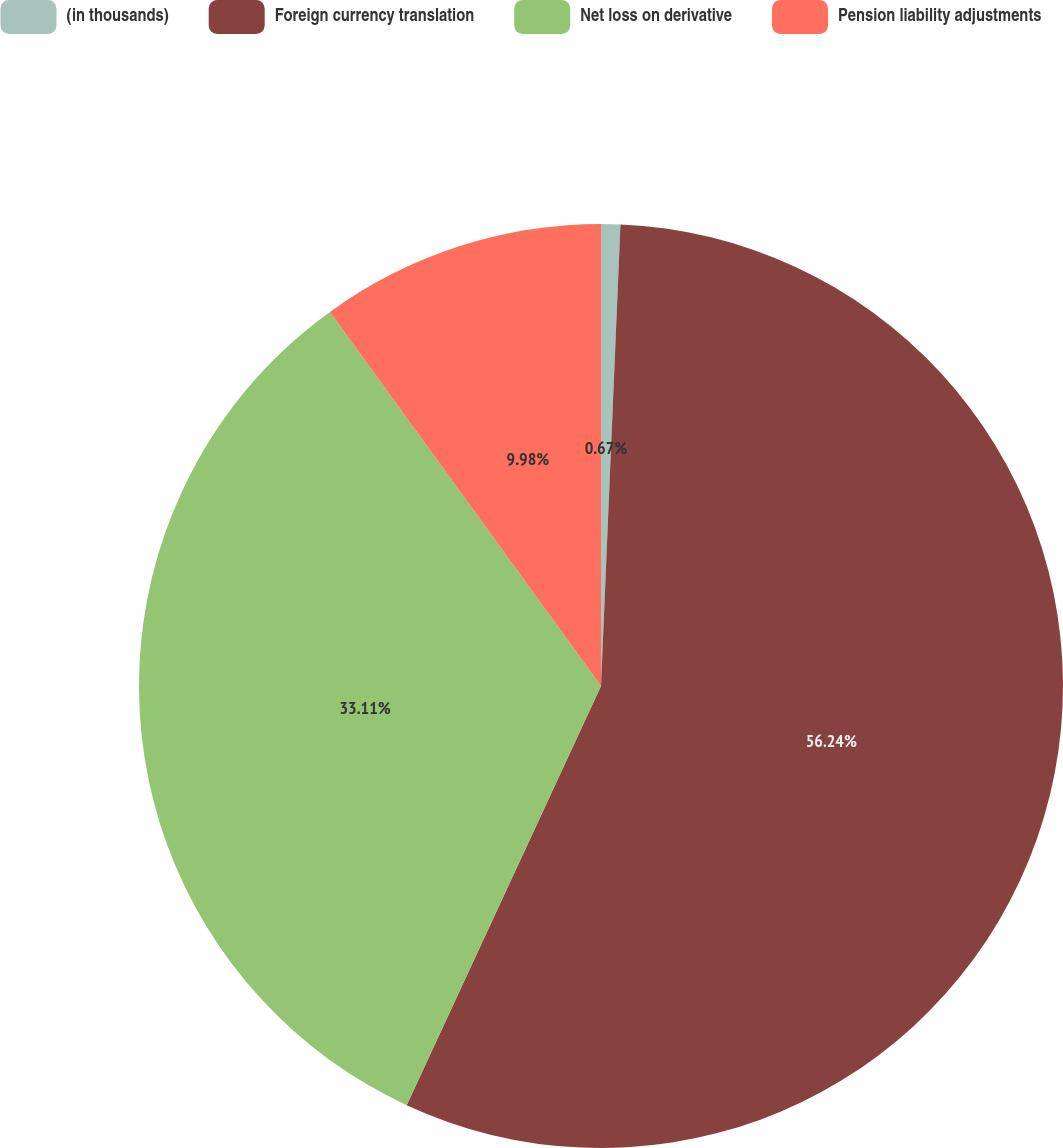Convert chart. <chart><loc_0><loc_0><loc_500><loc_500><pie_chart><fcel>(in thousands)<fcel>Foreign currency translation<fcel>Net loss on derivative<fcel>Pension liability adjustments<nl><fcel>0.67%<fcel>56.24%<fcel>33.11%<fcel>9.98%<nl></chart> 